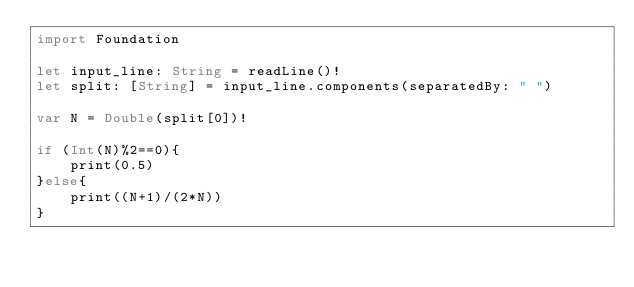<code> <loc_0><loc_0><loc_500><loc_500><_Swift_>import Foundation
 
let input_line: String = readLine()!
let split: [String] = input_line.components(separatedBy: " ")
 
var N = Double(split[0])!

if (Int(N)%2==0){
    print(0.5)
}else{
    print((N+1)/(2*N))
}
</code> 